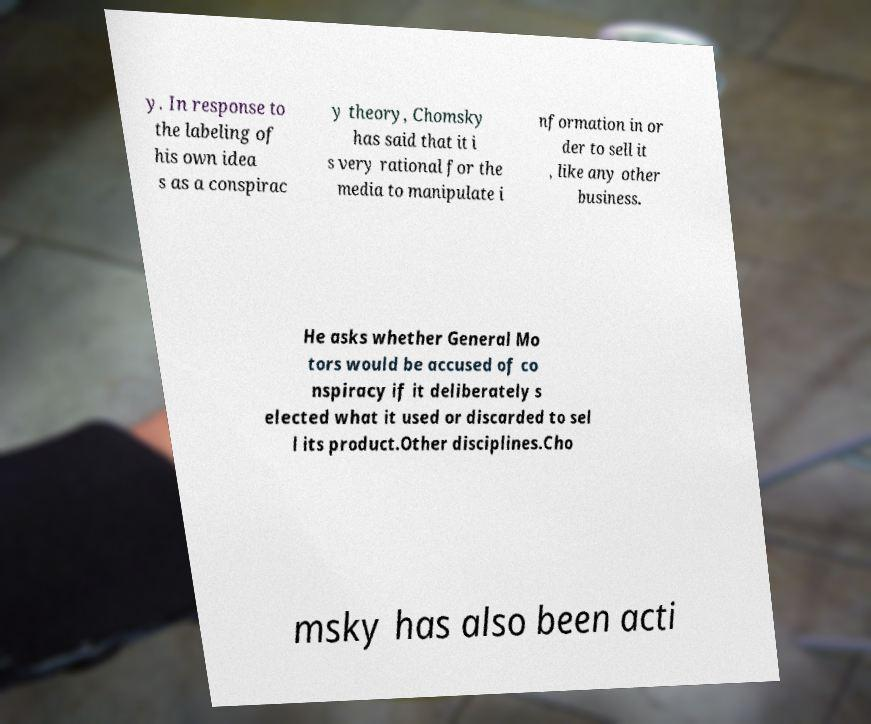I need the written content from this picture converted into text. Can you do that? y. In response to the labeling of his own idea s as a conspirac y theory, Chomsky has said that it i s very rational for the media to manipulate i nformation in or der to sell it , like any other business. He asks whether General Mo tors would be accused of co nspiracy if it deliberately s elected what it used or discarded to sel l its product.Other disciplines.Cho msky has also been acti 